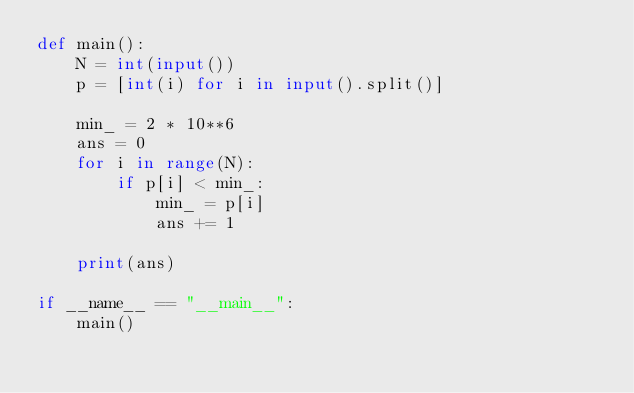Convert code to text. <code><loc_0><loc_0><loc_500><loc_500><_Python_>def main():
    N = int(input())
    p = [int(i) for i in input().split()]

    min_ = 2 * 10**6
    ans = 0
    for i in range(N):
        if p[i] < min_:
            min_ = p[i]
            ans += 1

    print(ans)

if __name__ == "__main__":
    main()
</code> 